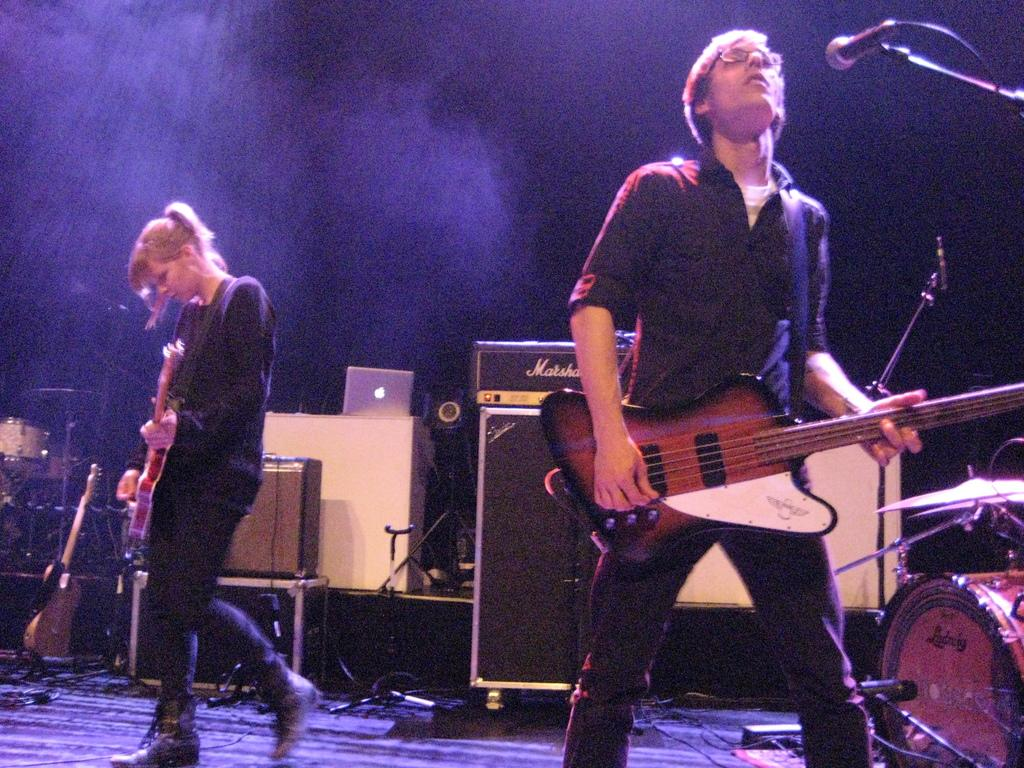What are the people in the image doing? The people in the image are playing musical instruments. Can you describe the setting where this activity is taking place? The setting is a stage, as indicated by the many objects placed on it. What type of train can be seen passing by in the image? There is no train present in the image; it features people playing musical instruments on a stage. How many volleyballs are visible on the stage in the image? There are no volleyballs present in the image; it features people playing musical instruments on a stage with many objects placed on it. 